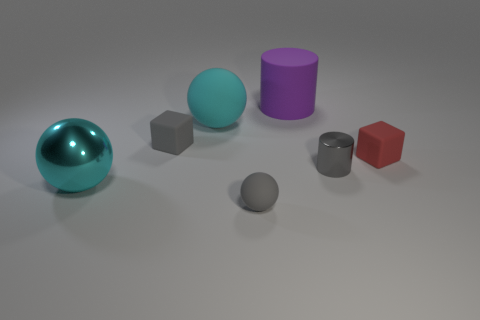Do the shiny sphere that is on the left side of the tiny matte ball and the tiny metal object have the same color?
Keep it short and to the point. No. What number of red objects are matte things or matte spheres?
Your answer should be compact. 1. What is the color of the large sphere in front of the small object left of the tiny matte ball?
Keep it short and to the point. Cyan. There is a object that is the same color as the metal sphere; what is its material?
Keep it short and to the point. Rubber. There is a matte cube that is left of the small matte sphere; what is its color?
Make the answer very short. Gray. Is the size of the cyan thing behind the red matte block the same as the gray rubber cube?
Provide a succinct answer. No. There is another thing that is the same color as the large metallic object; what size is it?
Your answer should be compact. Large. Are there any purple rubber things of the same size as the red rubber block?
Make the answer very short. No. There is a tiny matte object that is right of the small matte sphere; does it have the same color as the sphere in front of the big cyan shiny thing?
Your answer should be compact. No. Are there any small shiny things of the same color as the tiny shiny cylinder?
Make the answer very short. No. 